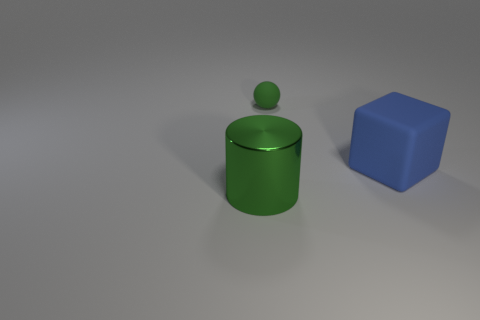Are there any other things that are the same size as the rubber ball?
Keep it short and to the point. No. Is there a big thing that has the same color as the ball?
Keep it short and to the point. Yes. The other thing that is the same material as the tiny object is what size?
Provide a succinct answer. Large. Do the large metallic cylinder and the sphere have the same color?
Ensure brevity in your answer.  Yes. What number of things are the same size as the cylinder?
Offer a terse response. 1. What shape is the small rubber object that is the same color as the cylinder?
Give a very brief answer. Sphere. Is there a small green ball behind the metallic thing that is in front of the large matte object?
Ensure brevity in your answer.  Yes. How many objects are tiny green rubber spheres that are on the right side of the green metal object or tiny rubber objects?
Offer a very short reply. 1. How many large blue rubber cylinders are there?
Offer a terse response. 0. What is the shape of the object that is made of the same material as the big block?
Keep it short and to the point. Sphere. 